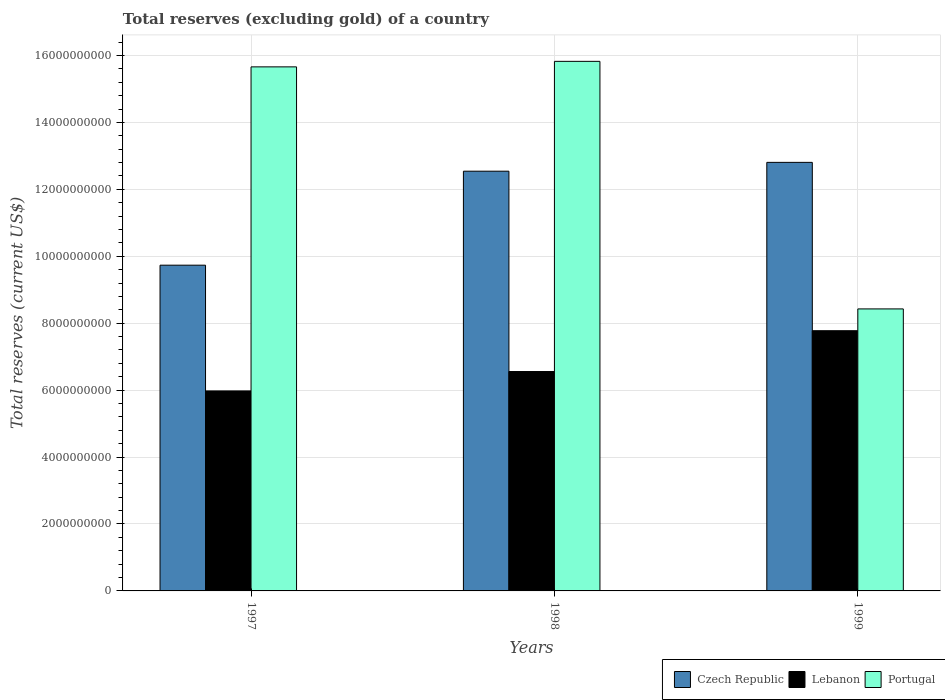Are the number of bars on each tick of the X-axis equal?
Your answer should be very brief. Yes. How many bars are there on the 2nd tick from the right?
Offer a very short reply. 3. What is the label of the 1st group of bars from the left?
Ensure brevity in your answer.  1997. What is the total reserves (excluding gold) in Czech Republic in 1998?
Make the answer very short. 1.25e+1. Across all years, what is the maximum total reserves (excluding gold) in Czech Republic?
Offer a very short reply. 1.28e+1. Across all years, what is the minimum total reserves (excluding gold) in Czech Republic?
Provide a succinct answer. 9.73e+09. In which year was the total reserves (excluding gold) in Portugal maximum?
Give a very brief answer. 1998. What is the total total reserves (excluding gold) in Lebanon in the graph?
Your answer should be compact. 2.03e+1. What is the difference between the total reserves (excluding gold) in Portugal in 1998 and that in 1999?
Give a very brief answer. 7.40e+09. What is the difference between the total reserves (excluding gold) in Lebanon in 1997 and the total reserves (excluding gold) in Portugal in 1999?
Provide a succinct answer. -2.45e+09. What is the average total reserves (excluding gold) in Lebanon per year?
Your response must be concise. 6.77e+09. In the year 1999, what is the difference between the total reserves (excluding gold) in Portugal and total reserves (excluding gold) in Czech Republic?
Keep it short and to the point. -4.38e+09. What is the ratio of the total reserves (excluding gold) in Lebanon in 1998 to that in 1999?
Provide a succinct answer. 0.84. What is the difference between the highest and the second highest total reserves (excluding gold) in Lebanon?
Your answer should be very brief. 1.22e+09. What is the difference between the highest and the lowest total reserves (excluding gold) in Lebanon?
Offer a very short reply. 1.80e+09. Is the sum of the total reserves (excluding gold) in Portugal in 1997 and 1999 greater than the maximum total reserves (excluding gold) in Czech Republic across all years?
Your response must be concise. Yes. What does the 1st bar from the left in 1998 represents?
Provide a succinct answer. Czech Republic. What does the 1st bar from the right in 1998 represents?
Keep it short and to the point. Portugal. Is it the case that in every year, the sum of the total reserves (excluding gold) in Czech Republic and total reserves (excluding gold) in Portugal is greater than the total reserves (excluding gold) in Lebanon?
Make the answer very short. Yes. How many bars are there?
Keep it short and to the point. 9. Are all the bars in the graph horizontal?
Your answer should be very brief. No. How many years are there in the graph?
Offer a terse response. 3. How are the legend labels stacked?
Offer a very short reply. Horizontal. What is the title of the graph?
Ensure brevity in your answer.  Total reserves (excluding gold) of a country. What is the label or title of the Y-axis?
Keep it short and to the point. Total reserves (current US$). What is the Total reserves (current US$) in Czech Republic in 1997?
Provide a succinct answer. 9.73e+09. What is the Total reserves (current US$) in Lebanon in 1997?
Your answer should be compact. 5.98e+09. What is the Total reserves (current US$) in Portugal in 1997?
Ensure brevity in your answer.  1.57e+1. What is the Total reserves (current US$) in Czech Republic in 1998?
Give a very brief answer. 1.25e+1. What is the Total reserves (current US$) in Lebanon in 1998?
Make the answer very short. 6.56e+09. What is the Total reserves (current US$) of Portugal in 1998?
Keep it short and to the point. 1.58e+1. What is the Total reserves (current US$) in Czech Republic in 1999?
Your answer should be compact. 1.28e+1. What is the Total reserves (current US$) of Lebanon in 1999?
Ensure brevity in your answer.  7.78e+09. What is the Total reserves (current US$) of Portugal in 1999?
Make the answer very short. 8.43e+09. Across all years, what is the maximum Total reserves (current US$) of Czech Republic?
Your answer should be very brief. 1.28e+1. Across all years, what is the maximum Total reserves (current US$) in Lebanon?
Make the answer very short. 7.78e+09. Across all years, what is the maximum Total reserves (current US$) of Portugal?
Your answer should be compact. 1.58e+1. Across all years, what is the minimum Total reserves (current US$) of Czech Republic?
Your answer should be compact. 9.73e+09. Across all years, what is the minimum Total reserves (current US$) in Lebanon?
Ensure brevity in your answer.  5.98e+09. Across all years, what is the minimum Total reserves (current US$) in Portugal?
Your response must be concise. 8.43e+09. What is the total Total reserves (current US$) in Czech Republic in the graph?
Your response must be concise. 3.51e+1. What is the total Total reserves (current US$) of Lebanon in the graph?
Your answer should be compact. 2.03e+1. What is the total Total reserves (current US$) of Portugal in the graph?
Provide a succinct answer. 3.99e+1. What is the difference between the Total reserves (current US$) of Czech Republic in 1997 and that in 1998?
Offer a very short reply. -2.81e+09. What is the difference between the Total reserves (current US$) in Lebanon in 1997 and that in 1998?
Make the answer very short. -5.80e+08. What is the difference between the Total reserves (current US$) in Portugal in 1997 and that in 1998?
Your response must be concise. -1.65e+08. What is the difference between the Total reserves (current US$) of Czech Republic in 1997 and that in 1999?
Provide a short and direct response. -3.07e+09. What is the difference between the Total reserves (current US$) in Lebanon in 1997 and that in 1999?
Offer a terse response. -1.80e+09. What is the difference between the Total reserves (current US$) of Portugal in 1997 and that in 1999?
Your response must be concise. 7.23e+09. What is the difference between the Total reserves (current US$) of Czech Republic in 1998 and that in 1999?
Offer a very short reply. -2.64e+08. What is the difference between the Total reserves (current US$) of Lebanon in 1998 and that in 1999?
Provide a succinct answer. -1.22e+09. What is the difference between the Total reserves (current US$) of Portugal in 1998 and that in 1999?
Make the answer very short. 7.40e+09. What is the difference between the Total reserves (current US$) of Czech Republic in 1997 and the Total reserves (current US$) of Lebanon in 1998?
Make the answer very short. 3.18e+09. What is the difference between the Total reserves (current US$) of Czech Republic in 1997 and the Total reserves (current US$) of Portugal in 1998?
Ensure brevity in your answer.  -6.09e+09. What is the difference between the Total reserves (current US$) in Lebanon in 1997 and the Total reserves (current US$) in Portugal in 1998?
Your response must be concise. -9.85e+09. What is the difference between the Total reserves (current US$) in Czech Republic in 1997 and the Total reserves (current US$) in Lebanon in 1999?
Ensure brevity in your answer.  1.96e+09. What is the difference between the Total reserves (current US$) in Czech Republic in 1997 and the Total reserves (current US$) in Portugal in 1999?
Offer a terse response. 1.31e+09. What is the difference between the Total reserves (current US$) in Lebanon in 1997 and the Total reserves (current US$) in Portugal in 1999?
Provide a short and direct response. -2.45e+09. What is the difference between the Total reserves (current US$) in Czech Republic in 1998 and the Total reserves (current US$) in Lebanon in 1999?
Give a very brief answer. 4.77e+09. What is the difference between the Total reserves (current US$) of Czech Republic in 1998 and the Total reserves (current US$) of Portugal in 1999?
Your response must be concise. 4.11e+09. What is the difference between the Total reserves (current US$) in Lebanon in 1998 and the Total reserves (current US$) in Portugal in 1999?
Your answer should be very brief. -1.87e+09. What is the average Total reserves (current US$) in Czech Republic per year?
Ensure brevity in your answer.  1.17e+1. What is the average Total reserves (current US$) of Lebanon per year?
Your answer should be compact. 6.77e+09. What is the average Total reserves (current US$) of Portugal per year?
Ensure brevity in your answer.  1.33e+1. In the year 1997, what is the difference between the Total reserves (current US$) in Czech Republic and Total reserves (current US$) in Lebanon?
Keep it short and to the point. 3.76e+09. In the year 1997, what is the difference between the Total reserves (current US$) in Czech Republic and Total reserves (current US$) in Portugal?
Offer a terse response. -5.93e+09. In the year 1997, what is the difference between the Total reserves (current US$) of Lebanon and Total reserves (current US$) of Portugal?
Give a very brief answer. -9.68e+09. In the year 1998, what is the difference between the Total reserves (current US$) of Czech Republic and Total reserves (current US$) of Lebanon?
Offer a terse response. 5.99e+09. In the year 1998, what is the difference between the Total reserves (current US$) in Czech Republic and Total reserves (current US$) in Portugal?
Provide a short and direct response. -3.28e+09. In the year 1998, what is the difference between the Total reserves (current US$) of Lebanon and Total reserves (current US$) of Portugal?
Offer a terse response. -9.27e+09. In the year 1999, what is the difference between the Total reserves (current US$) of Czech Republic and Total reserves (current US$) of Lebanon?
Provide a short and direct response. 5.03e+09. In the year 1999, what is the difference between the Total reserves (current US$) in Czech Republic and Total reserves (current US$) in Portugal?
Your response must be concise. 4.38e+09. In the year 1999, what is the difference between the Total reserves (current US$) of Lebanon and Total reserves (current US$) of Portugal?
Your answer should be very brief. -6.51e+08. What is the ratio of the Total reserves (current US$) in Czech Republic in 1997 to that in 1998?
Your answer should be compact. 0.78. What is the ratio of the Total reserves (current US$) in Lebanon in 1997 to that in 1998?
Give a very brief answer. 0.91. What is the ratio of the Total reserves (current US$) of Portugal in 1997 to that in 1998?
Your answer should be compact. 0.99. What is the ratio of the Total reserves (current US$) in Czech Republic in 1997 to that in 1999?
Your response must be concise. 0.76. What is the ratio of the Total reserves (current US$) in Lebanon in 1997 to that in 1999?
Give a very brief answer. 0.77. What is the ratio of the Total reserves (current US$) in Portugal in 1997 to that in 1999?
Your response must be concise. 1.86. What is the ratio of the Total reserves (current US$) of Czech Republic in 1998 to that in 1999?
Your response must be concise. 0.98. What is the ratio of the Total reserves (current US$) of Lebanon in 1998 to that in 1999?
Your response must be concise. 0.84. What is the ratio of the Total reserves (current US$) of Portugal in 1998 to that in 1999?
Your answer should be very brief. 1.88. What is the difference between the highest and the second highest Total reserves (current US$) of Czech Republic?
Keep it short and to the point. 2.64e+08. What is the difference between the highest and the second highest Total reserves (current US$) in Lebanon?
Provide a succinct answer. 1.22e+09. What is the difference between the highest and the second highest Total reserves (current US$) of Portugal?
Your answer should be compact. 1.65e+08. What is the difference between the highest and the lowest Total reserves (current US$) in Czech Republic?
Provide a short and direct response. 3.07e+09. What is the difference between the highest and the lowest Total reserves (current US$) of Lebanon?
Your response must be concise. 1.80e+09. What is the difference between the highest and the lowest Total reserves (current US$) of Portugal?
Your answer should be very brief. 7.40e+09. 